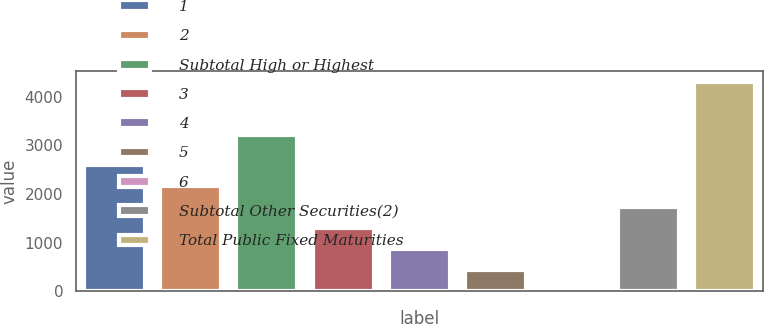Convert chart. <chart><loc_0><loc_0><loc_500><loc_500><bar_chart><fcel>1<fcel>2<fcel>Subtotal High or Highest<fcel>3<fcel>4<fcel>5<fcel>6<fcel>Subtotal Other Securities(2)<fcel>Total Public Fixed Maturities<nl><fcel>2587.6<fcel>2156.5<fcel>3209<fcel>1294.3<fcel>863.2<fcel>432.1<fcel>1<fcel>1725.4<fcel>4312<nl></chart> 